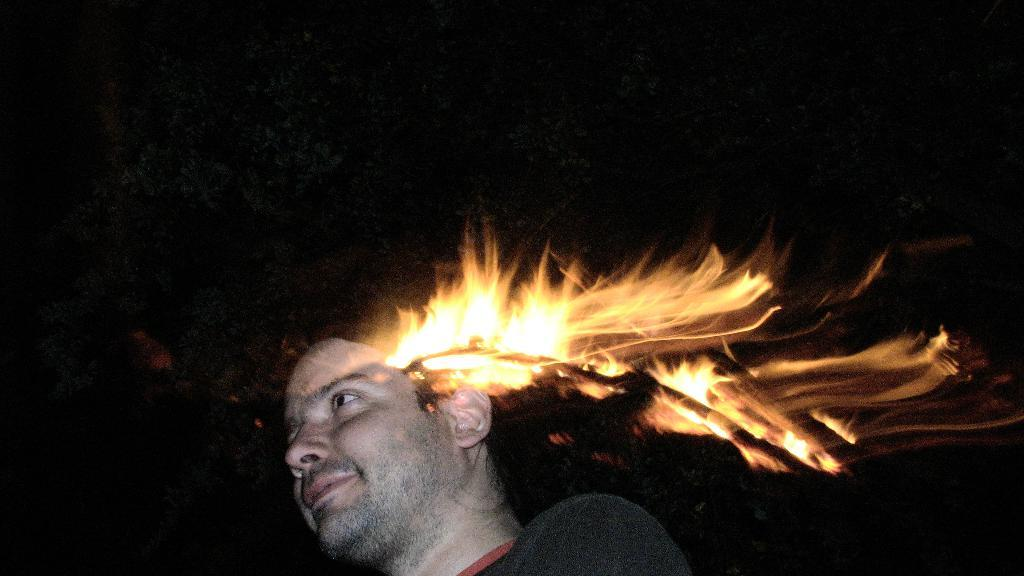What is the person in the image wearing? The person in the image is wearing a red and black color dress. What can be seen in the image besides the person? There is a fire visible in the image. What is visible in the background of the image? There are many trees in the background of the image. What type of paste is being traded in the image? There is no mention of paste or trading in the image; it features a person wearing a dress and a fire in the background. 